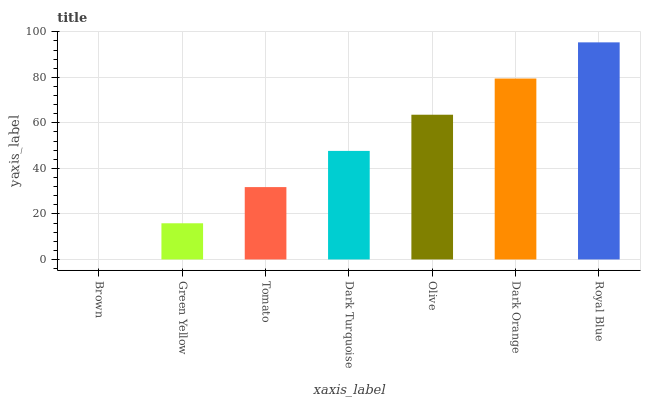Is Brown the minimum?
Answer yes or no. Yes. Is Royal Blue the maximum?
Answer yes or no. Yes. Is Green Yellow the minimum?
Answer yes or no. No. Is Green Yellow the maximum?
Answer yes or no. No. Is Green Yellow greater than Brown?
Answer yes or no. Yes. Is Brown less than Green Yellow?
Answer yes or no. Yes. Is Brown greater than Green Yellow?
Answer yes or no. No. Is Green Yellow less than Brown?
Answer yes or no. No. Is Dark Turquoise the high median?
Answer yes or no. Yes. Is Dark Turquoise the low median?
Answer yes or no. Yes. Is Green Yellow the high median?
Answer yes or no. No. Is Green Yellow the low median?
Answer yes or no. No. 